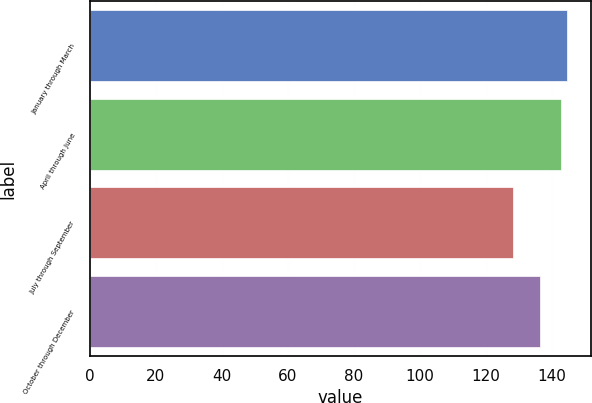Convert chart to OTSL. <chart><loc_0><loc_0><loc_500><loc_500><bar_chart><fcel>January through March<fcel>April through June<fcel>July through September<fcel>October through December<nl><fcel>144.57<fcel>142.99<fcel>128.22<fcel>136.55<nl></chart> 